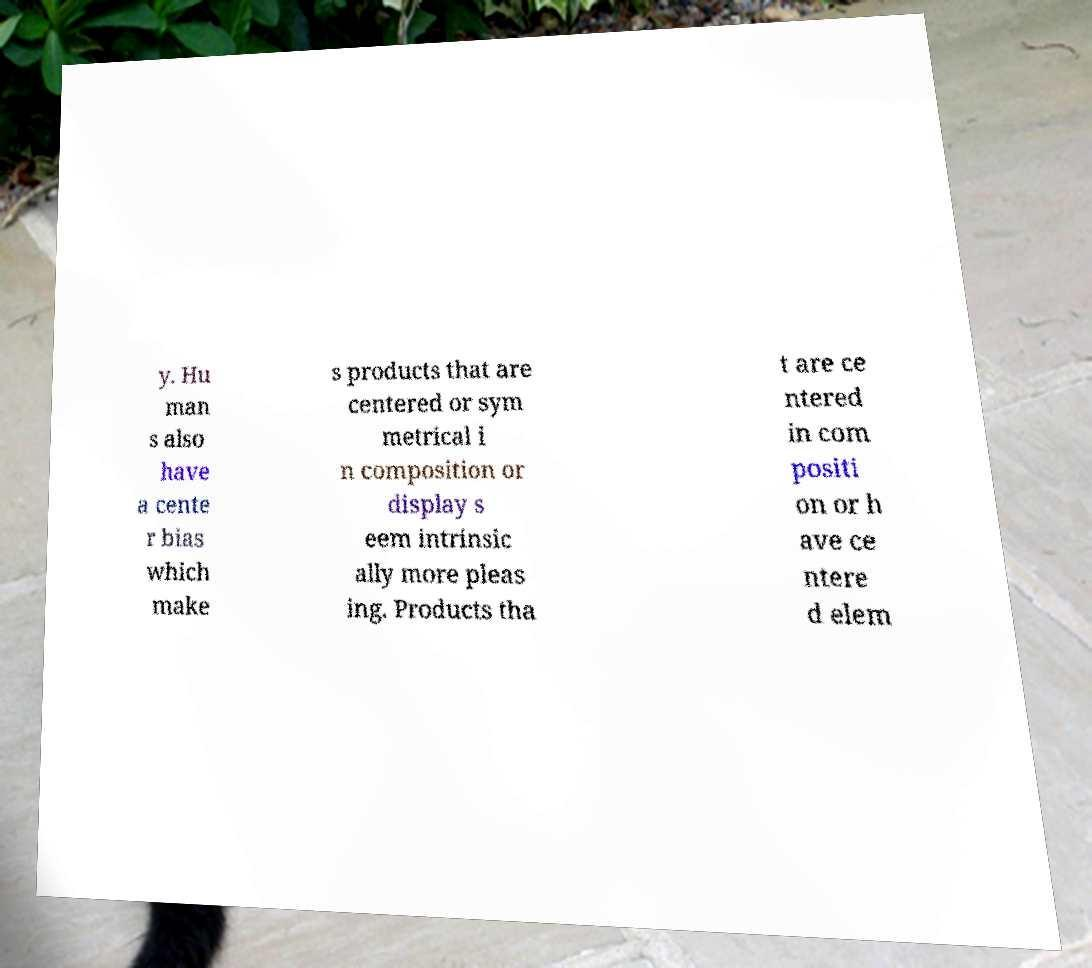Could you assist in decoding the text presented in this image and type it out clearly? y. Hu man s also have a cente r bias which make s products that are centered or sym metrical i n composition or display s eem intrinsic ally more pleas ing. Products tha t are ce ntered in com positi on or h ave ce ntere d elem 